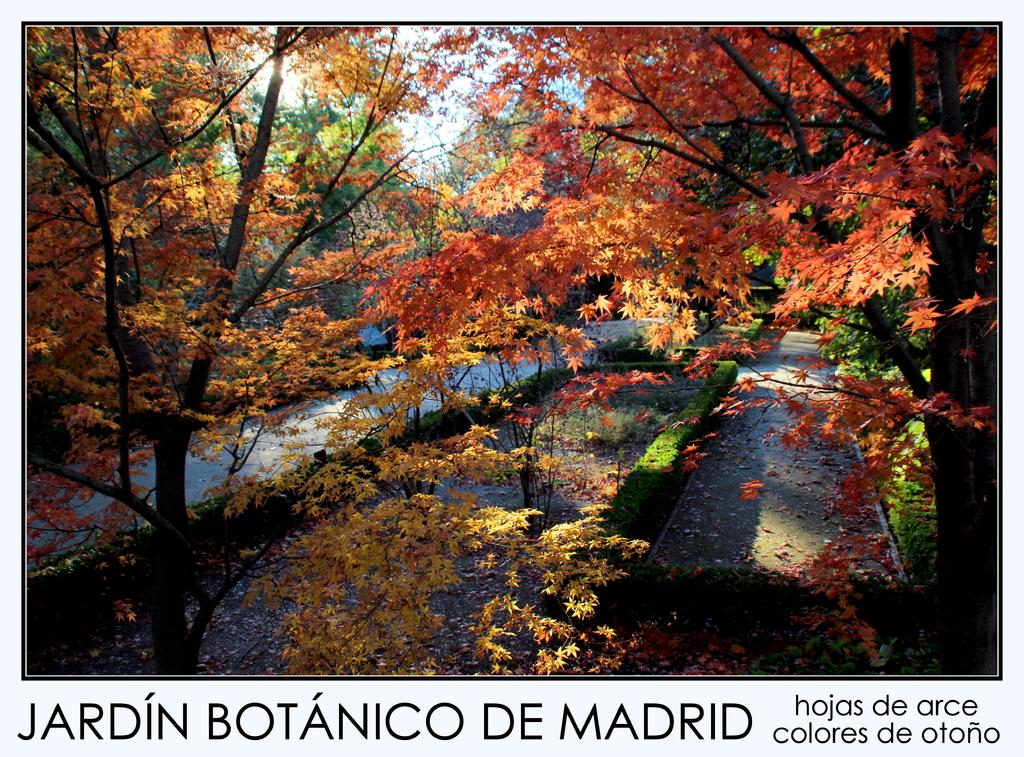What type of visual is the image? The image is a poster. What natural elements can be seen in the image? There are trees, plants, and grass in the image. Are there any man-made structures or features in the image? Yes, there is a road in the image. Is there any text present in the image? Yes, there is text at the bottom of the image. Can you tell me how many goats are grazing on the trail in the image? There are no goats or trails present in the image; it features a poster with trees, plants, grass, a road, and text. 